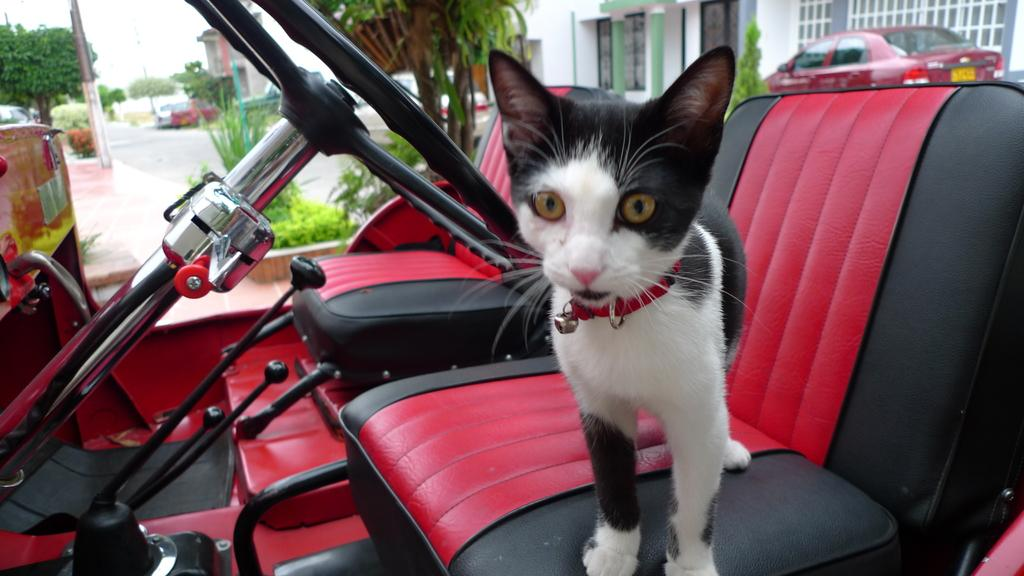What type of animal is in the image? There is a cat in the image. Where is the cat located? The cat is in a vehicle. What can be seen in the background of the image? There are trees, a road, other vehicles, and a building visible in the background. What type of turkey can be seen in the image? There is no turkey present in the image; it features a cat in a vehicle. Is the cat's sister also in the vehicle? There is no mention of a sister or any other animals in the image, only the cat is visible. 